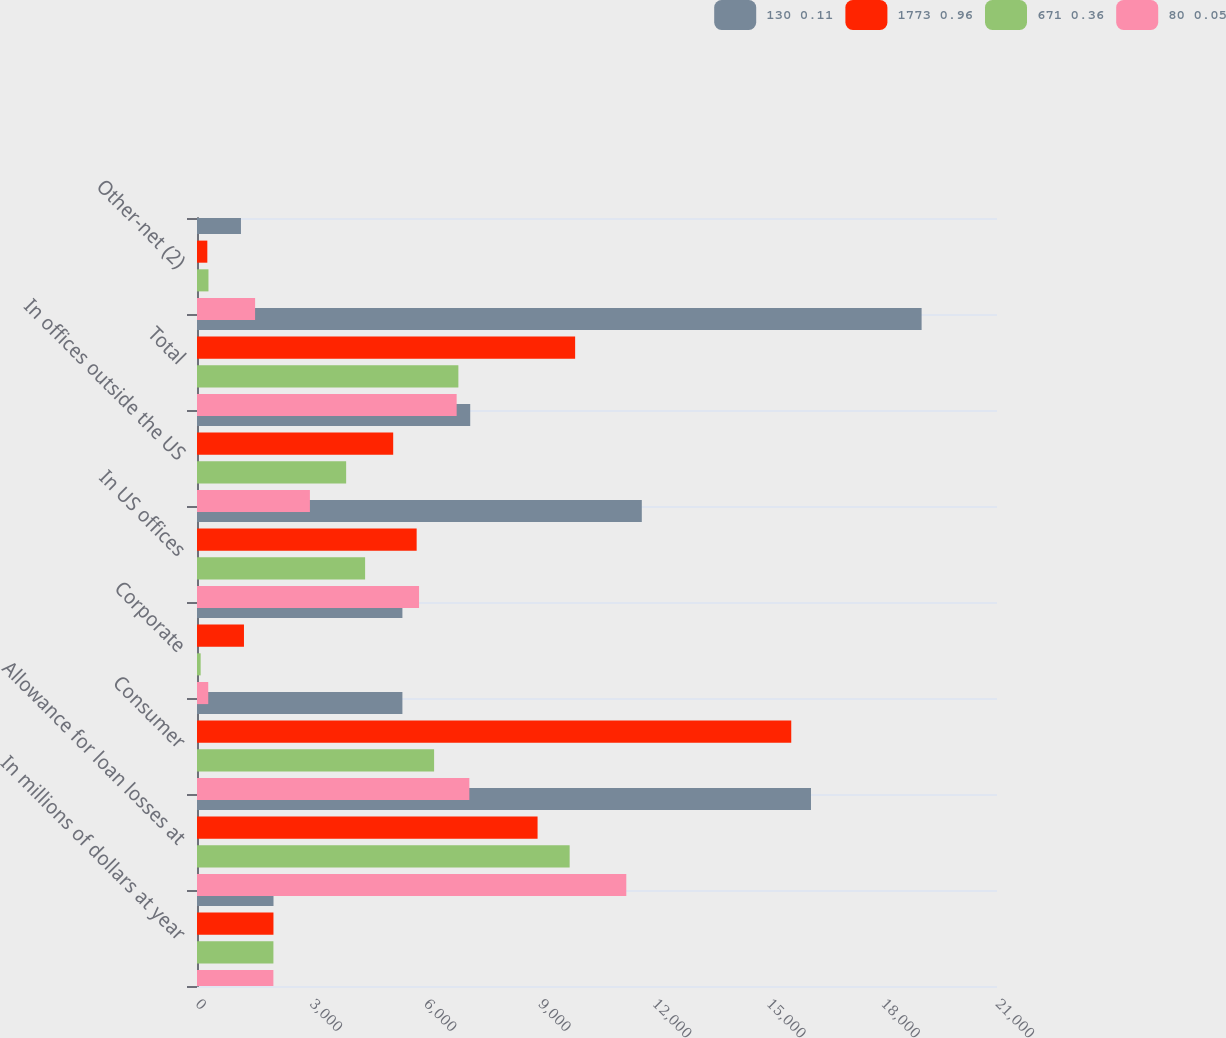<chart> <loc_0><loc_0><loc_500><loc_500><stacked_bar_chart><ecel><fcel>In millions of dollars at year<fcel>Allowance for loan losses at<fcel>Consumer<fcel>Corporate<fcel>In US offices<fcel>In offices outside the US<fcel>Total<fcel>Other-net (2)<nl><fcel>130 0.11<fcel>2008<fcel>16117<fcel>5392<fcel>5392<fcel>11676<fcel>7172<fcel>19021<fcel>1154<nl><fcel>1773 0.96<fcel>2007<fcel>8940<fcel>15599<fcel>1233<fcel>5766<fcel>5150<fcel>9926<fcel>271<nl><fcel>671 0.36<fcel>2006<fcel>9782<fcel>6224<fcel>96<fcel>4413<fcel>3915<fcel>6861<fcel>301<nl><fcel>80 0.05<fcel>2005<fcel>11269<fcel>7149<fcel>295<fcel>5829<fcel>2964<fcel>6816<fcel>1525<nl></chart> 